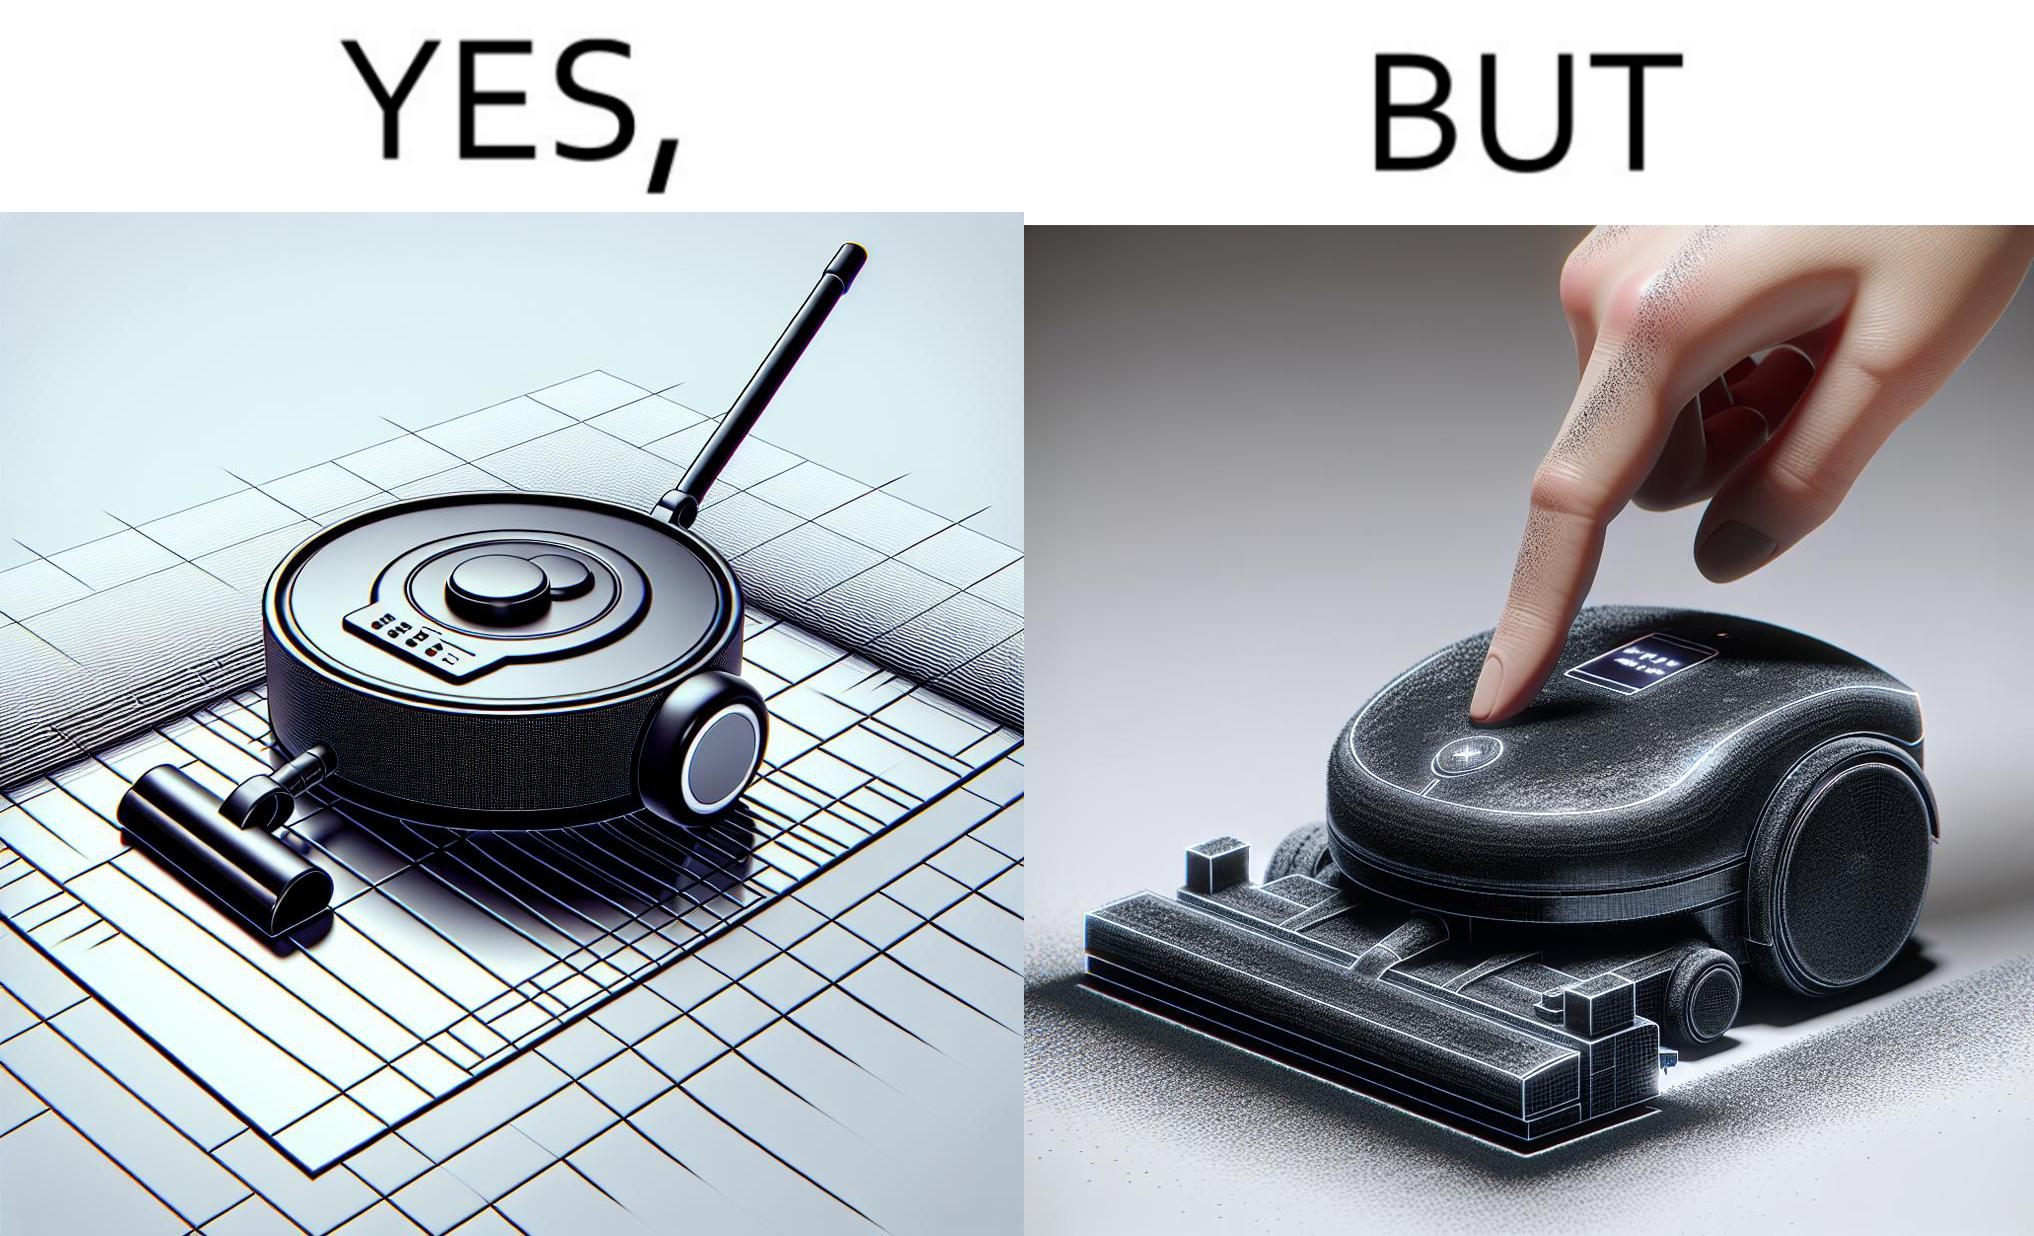Describe the contrast between the left and right parts of this image. In the left part of the image: A vacuum cleaning machine that goes around the floor on its own and cleans the floor. Everything  around it looks squeaky clean, and is shining. In the right part of the image: Close up of a vacuum cleaning machine that goes around the floor on its own and cleans the floor. Everything  around it looks squeaky clean, and is shining, but it has a lot of dust on it except one line on it that looks clean. A persons fingertip is visible, and it is covered in dust. 